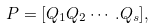Convert formula to latex. <formula><loc_0><loc_0><loc_500><loc_500>P = [ Q _ { 1 } Q _ { 2 } \cdots . Q _ { s } ] ,</formula> 